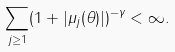Convert formula to latex. <formula><loc_0><loc_0><loc_500><loc_500>\sum _ { j \geq 1 } ( 1 + | \mu _ { j } ( \theta ) | ) ^ { - \gamma } < \infty .</formula> 